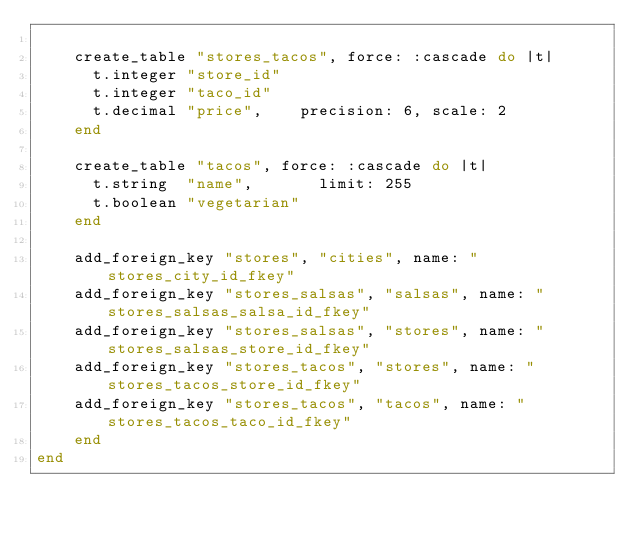<code> <loc_0><loc_0><loc_500><loc_500><_Ruby_>
    create_table "stores_tacos", force: :cascade do |t|
      t.integer "store_id"
      t.integer "taco_id"
      t.decimal "price",    precision: 6, scale: 2
    end

    create_table "tacos", force: :cascade do |t|
      t.string  "name",       limit: 255
      t.boolean "vegetarian"
    end

    add_foreign_key "stores", "cities", name: "stores_city_id_fkey"
    add_foreign_key "stores_salsas", "salsas", name: "stores_salsas_salsa_id_fkey"
    add_foreign_key "stores_salsas", "stores", name: "stores_salsas_store_id_fkey"
    add_foreign_key "stores_tacos", "stores", name: "stores_tacos_store_id_fkey"
    add_foreign_key "stores_tacos", "tacos", name: "stores_tacos_taco_id_fkey"
    end
end
</code> 